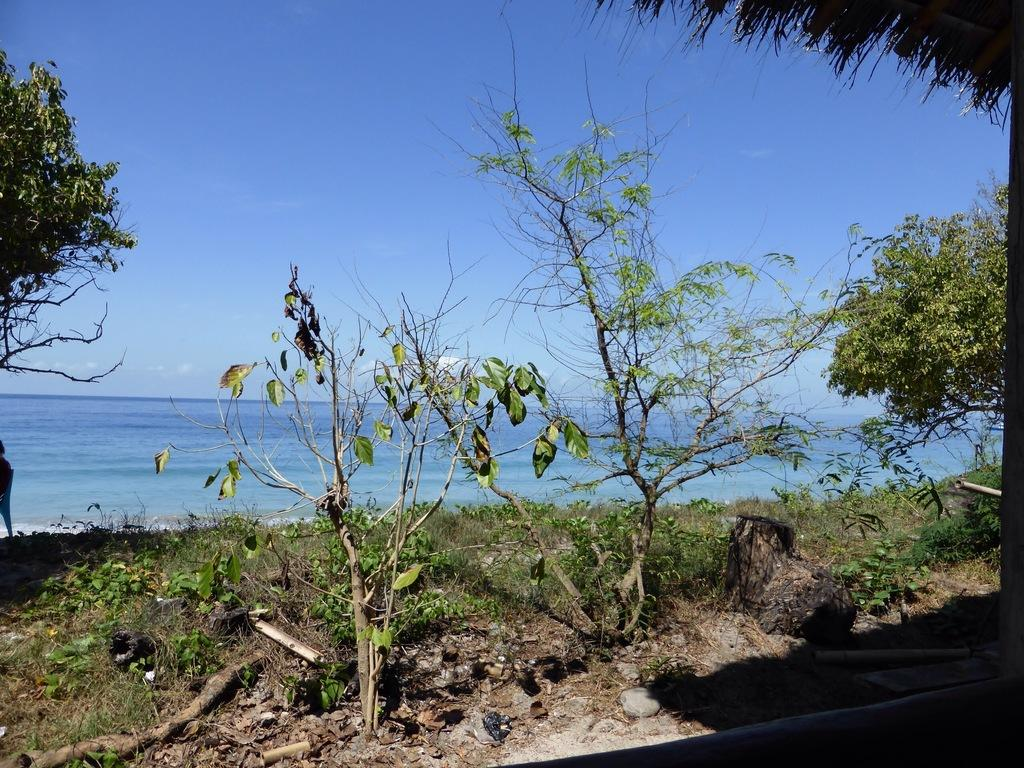What type of vegetation can be seen on the grassland in the image? There are plants and trees on the grassland in the image. What is located in the front of the image? There is a beach in the front of the image. What can be seen above the grassland and beach? The sky is visible above the grassland and beach. Where is the store located in the image? There is no store present in the image. What type of game is being played on the beach in the image? There is no game being played on the beach in the image. 